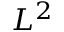<formula> <loc_0><loc_0><loc_500><loc_500>L ^ { 2 }</formula> 